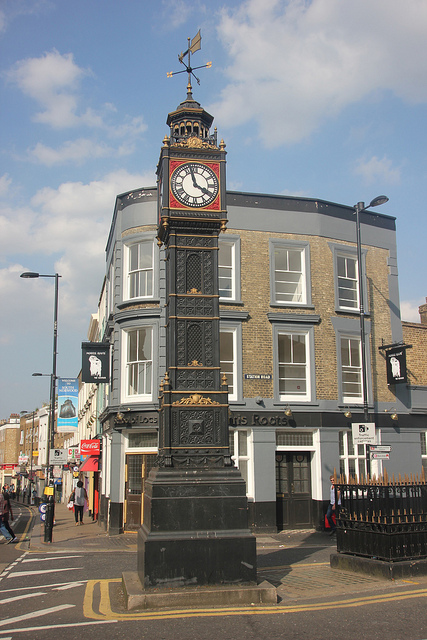This image captures a busy street. What activities do you think people are engaged in here? Given the presence of shops and pedestrians, it appears that people are likely engaged in various activities such as shopping, commuting, or socializing. The lively atmosphere suggests that this is a vibrant part of the city where both locals and tourists frequent. Imagine the street at a different time of day. How might it change? At a different time of day, the street might undergo several changes. For instance, in the early morning, it could be quieter with fewer people, primarily workers or joggers starting their day. In the evening, the street may light up with artificial lights, casting warm glows from the surrounding buildings, and bustling with people enjoying nightlife activities, dining in restaurants, or attending events. If you could add an element to this scene to change it entirely, what would it be? To radically transform the scene, imagine adding a festival with vibrant decorations, street performers, food stalls, and colourful banners. This would inject a sense of celebration and cultural festivity, making it a unique and lively environment that draws crowds from all over. 